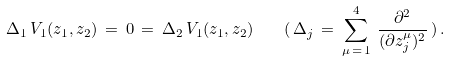<formula> <loc_0><loc_0><loc_500><loc_500>\Delta _ { 1 } \, V _ { 1 } ( z _ { 1 } , z _ { 2 } ) \, = \, 0 \, = \, \Delta _ { 2 } \, V _ { 1 } ( z _ { 1 } , z _ { 2 } ) \quad ( \, \Delta _ { j } \, = \, \sum _ { \mu \, = \, 1 } ^ { 4 } \, \frac { \partial ^ { 2 } } { ( \partial z _ { j } ^ { \mu } ) ^ { 2 } } \, ) \, .</formula> 